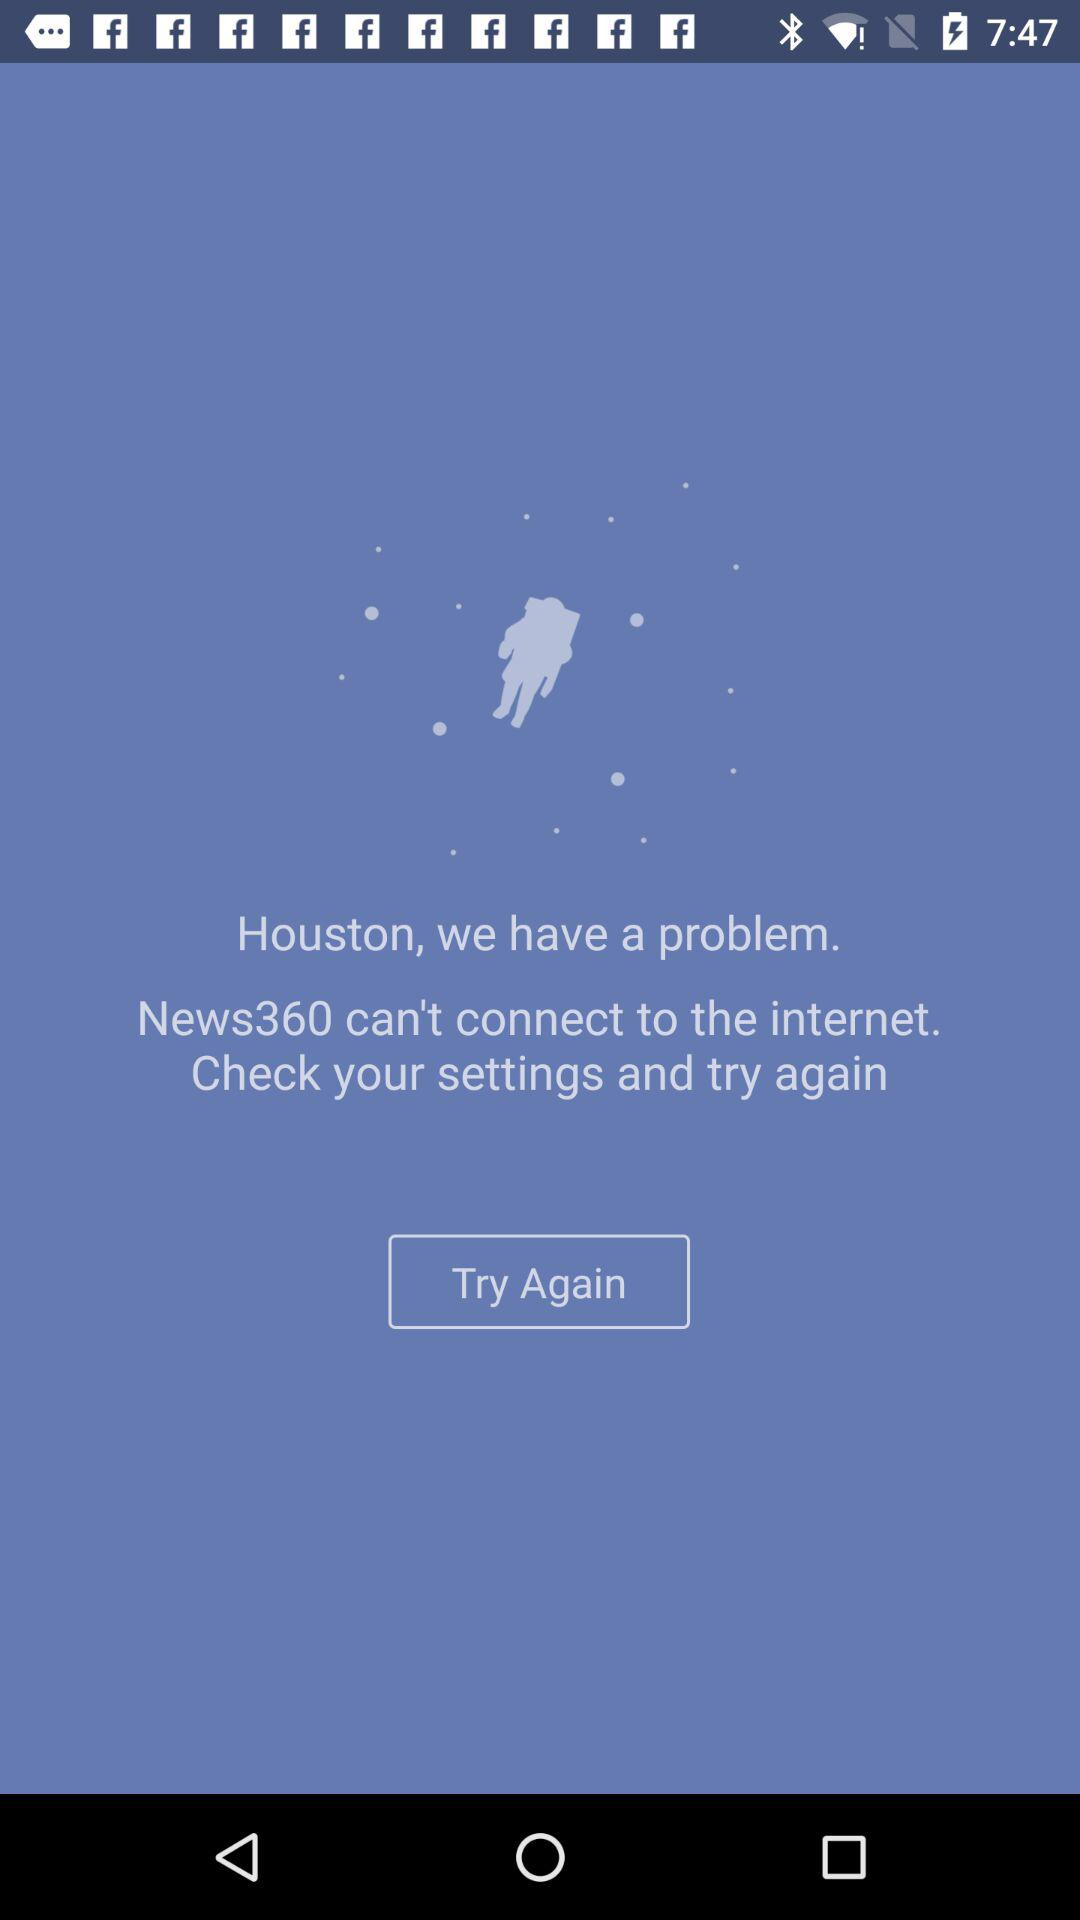Which WiFi connection is used?
When the provided information is insufficient, respond with <no answer>. <no answer> 